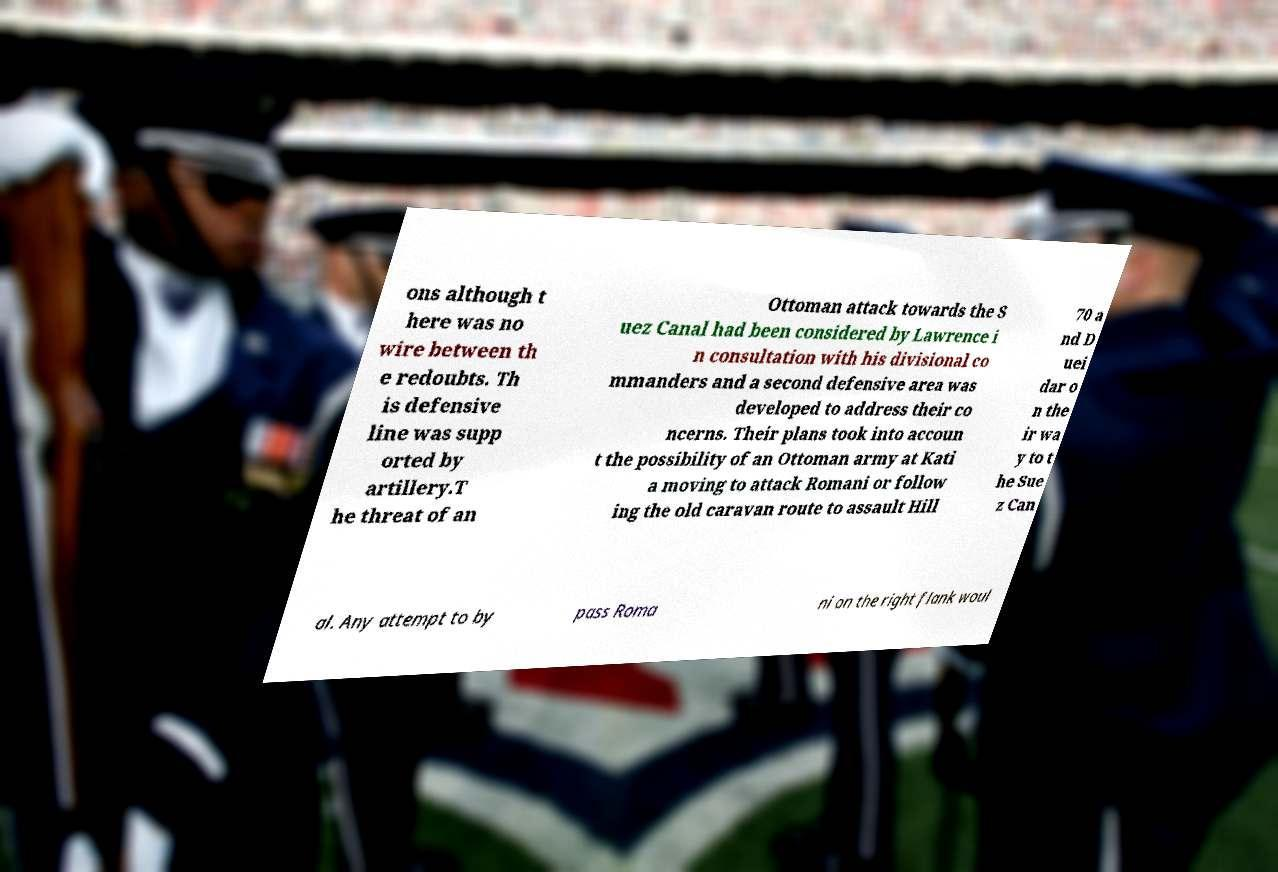Please identify and transcribe the text found in this image. ons although t here was no wire between th e redoubts. Th is defensive line was supp orted by artillery.T he threat of an Ottoman attack towards the S uez Canal had been considered by Lawrence i n consultation with his divisional co mmanders and a second defensive area was developed to address their co ncerns. Their plans took into accoun t the possibility of an Ottoman army at Kati a moving to attack Romani or follow ing the old caravan route to assault Hill 70 a nd D uei dar o n the ir wa y to t he Sue z Can al. Any attempt to by pass Roma ni on the right flank woul 